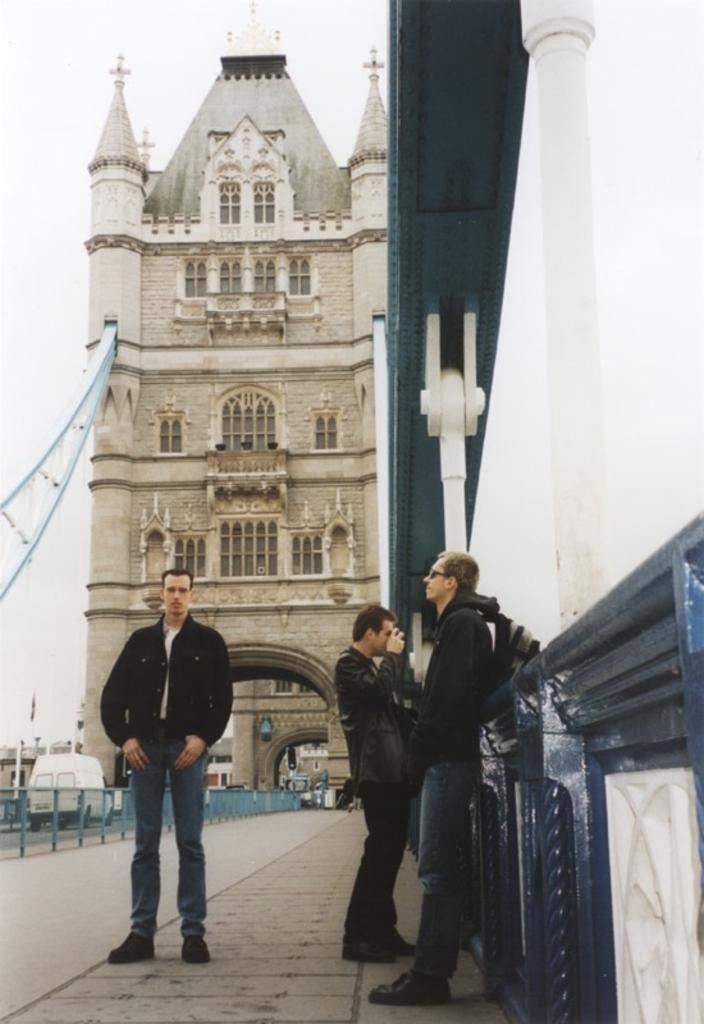Could you give a brief overview of what you see in this image? In this picture we can see three men standing on a platform, vehicle on the road, fence, buildings with windows and in the background we can see the sky. 